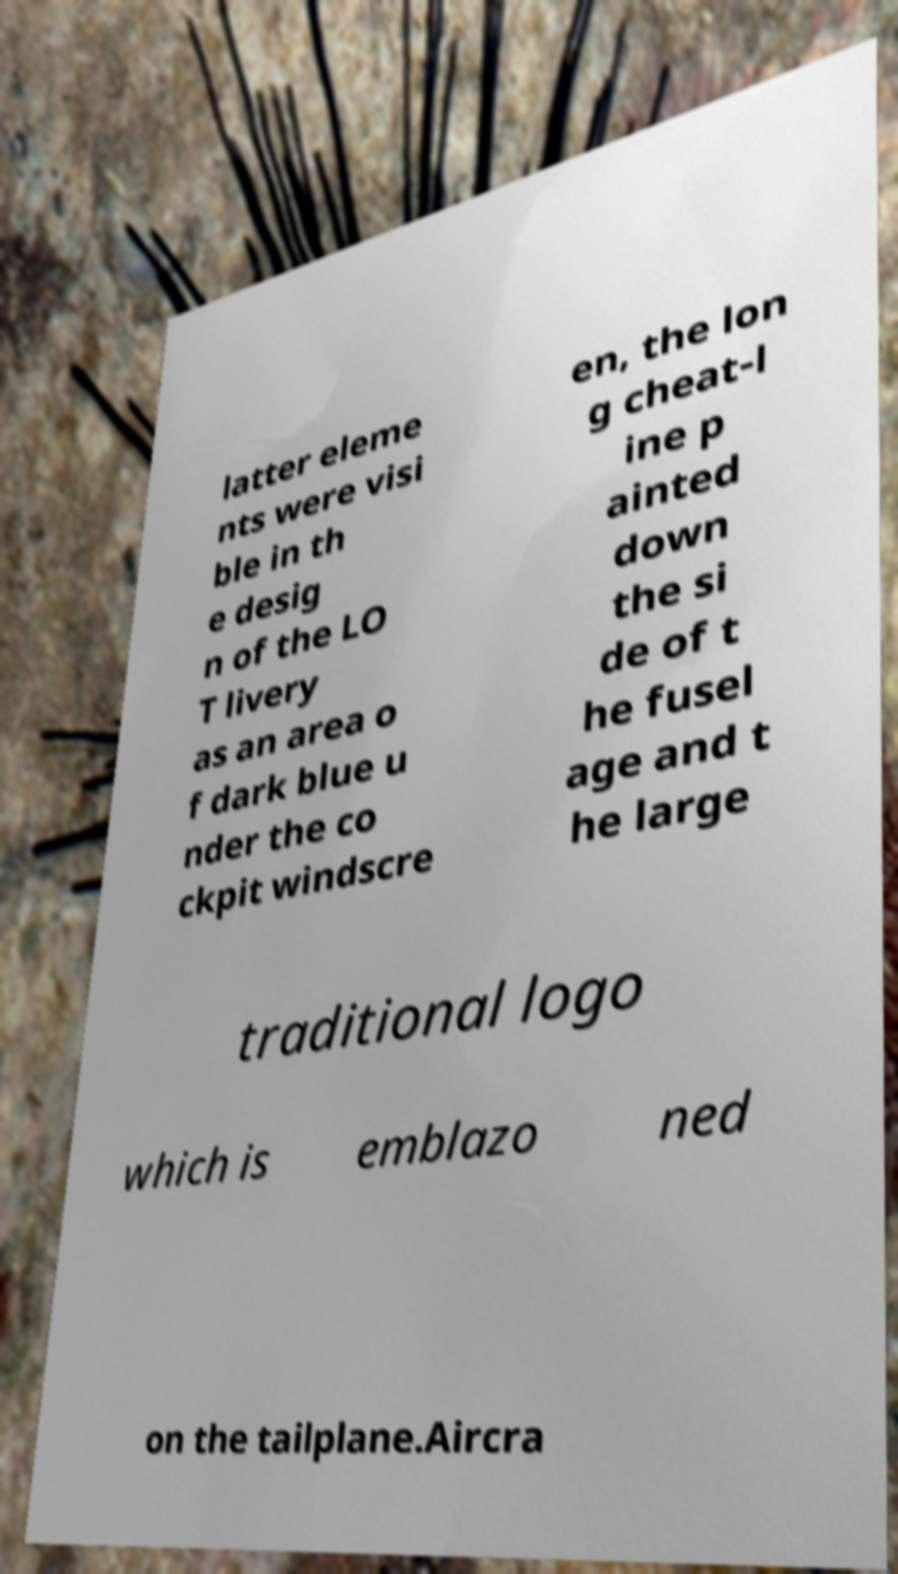Please read and relay the text visible in this image. What does it say? latter eleme nts were visi ble in th e desig n of the LO T livery as an area o f dark blue u nder the co ckpit windscre en, the lon g cheat-l ine p ainted down the si de of t he fusel age and t he large traditional logo which is emblazo ned on the tailplane.Aircra 